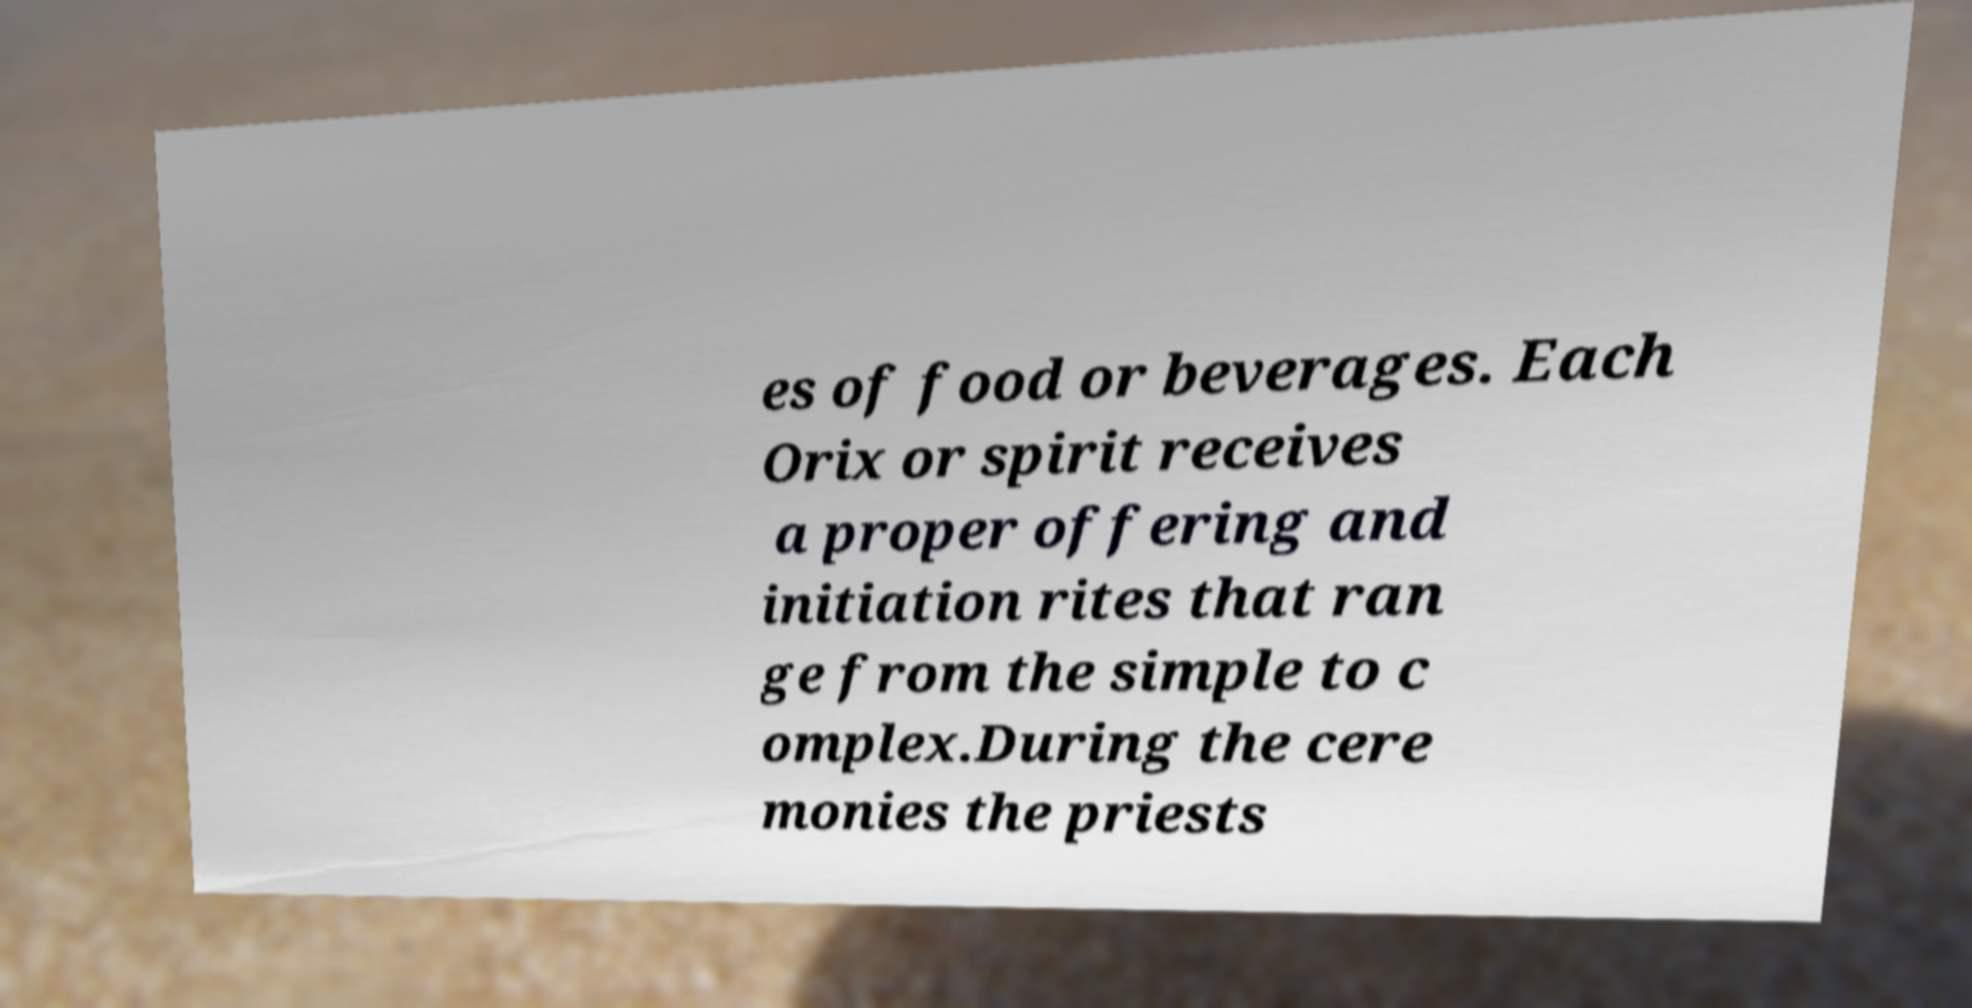Could you assist in decoding the text presented in this image and type it out clearly? es of food or beverages. Each Orix or spirit receives a proper offering and initiation rites that ran ge from the simple to c omplex.During the cere monies the priests 